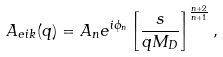Convert formula to latex. <formula><loc_0><loc_0><loc_500><loc_500>A _ { e i k } ( q ) = A _ { n } e ^ { i \phi _ { n } } \left [ \frac { s } { q M _ { D } } \right ] ^ { \frac { n + 2 } { n + 1 } } ,</formula> 